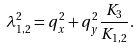Convert formula to latex. <formula><loc_0><loc_0><loc_500><loc_500>\lambda _ { 1 , 2 } ^ { 2 } = q _ { x } ^ { 2 } + q _ { y } ^ { 2 } \frac { K _ { 3 } } { K _ { 1 , 2 } } .</formula> 